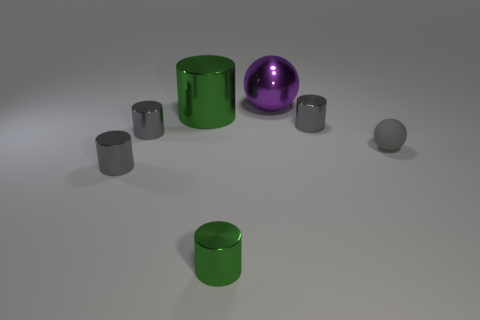Subtract all brown blocks. How many gray cylinders are left? 3 Subtract all small green cylinders. How many cylinders are left? 4 Subtract all cyan cylinders. Subtract all green spheres. How many cylinders are left? 5 Add 1 yellow metallic things. How many objects exist? 8 Subtract all cylinders. How many objects are left? 2 Add 2 green cylinders. How many green cylinders are left? 4 Add 1 gray shiny cylinders. How many gray shiny cylinders exist? 4 Subtract 0 cyan cylinders. How many objects are left? 7 Subtract all red blocks. Subtract all purple shiny spheres. How many objects are left? 6 